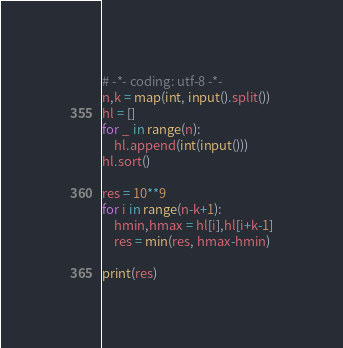Convert code to text. <code><loc_0><loc_0><loc_500><loc_500><_Python_># -*- coding: utf-8 -*-
n,k = map(int, input().split())
hl = []
for _ in range(n):
    hl.append(int(input()))
hl.sort()

res = 10**9
for i in range(n-k+1):
    hmin,hmax = hl[i],hl[i+k-1]
    res = min(res, hmax-hmin)

print(res)
</code> 